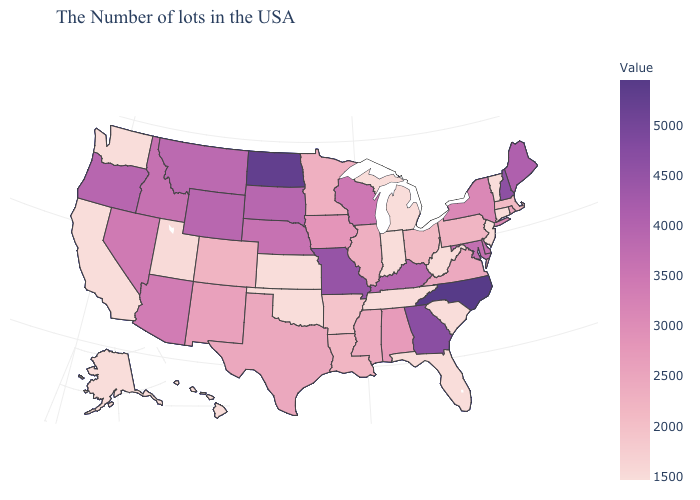Does Washington have a lower value than Pennsylvania?
Give a very brief answer. Yes. Which states have the highest value in the USA?
Answer briefly. North Carolina. Which states have the lowest value in the West?
Keep it brief. California, Washington, Alaska, Hawaii. Does Alabama have a lower value than Michigan?
Answer briefly. No. 